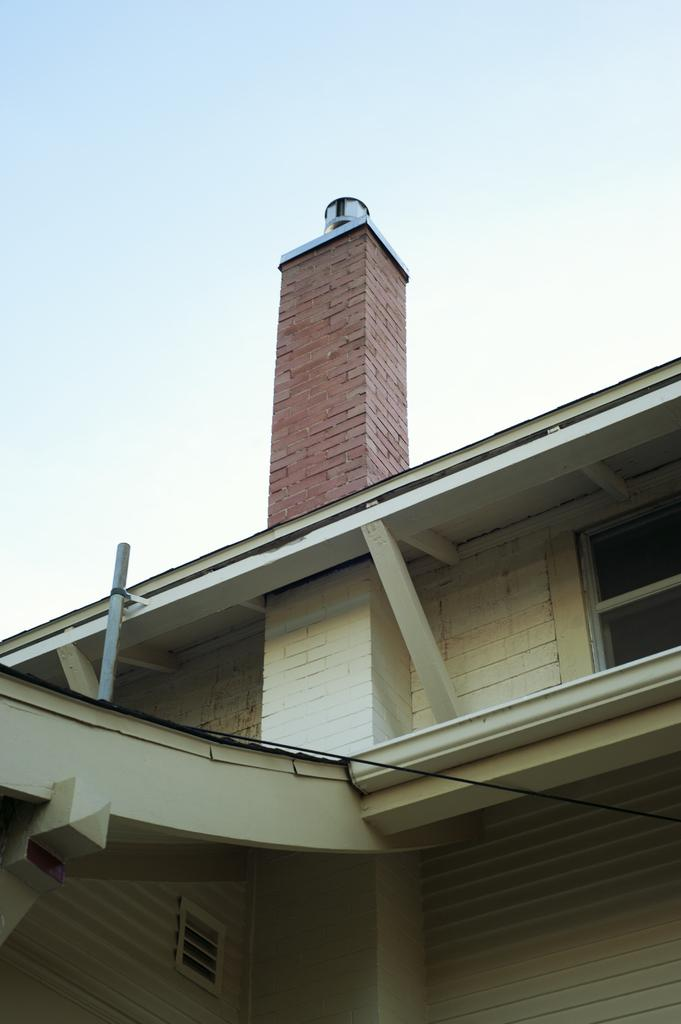What type of structure is featured in the image? There is a building wall in the image. What part of the building can be seen in the image? There are roofs visible in the image. What material is used for the pillars on top of the building? The pillars on top of the building are made of bricks. What can be seen in the background of the image? The sky is visible in the image. How many apples are placed on the roof of the building in the image? There are no apples present on the roof of the building in the image. What type of card is being used to support the building's structure? There is no card being used to support the building's structure; the pillars are made of bricks. 